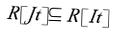<formula> <loc_0><loc_0><loc_500><loc_500>R [ J t ] \subseteq R [ I t ]</formula> 